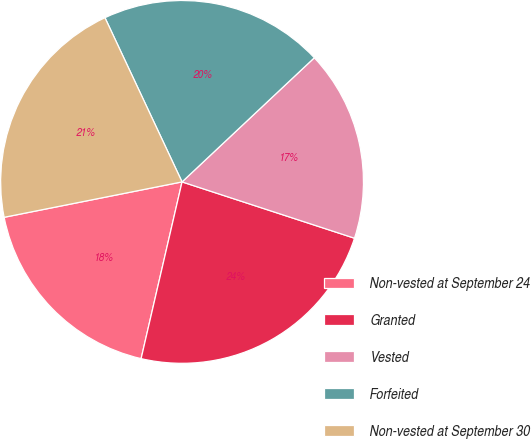Convert chart to OTSL. <chart><loc_0><loc_0><loc_500><loc_500><pie_chart><fcel>Non-vested at September 24<fcel>Granted<fcel>Vested<fcel>Forfeited<fcel>Non-vested at September 30<nl><fcel>18.25%<fcel>23.6%<fcel>17.02%<fcel>19.99%<fcel>21.14%<nl></chart> 